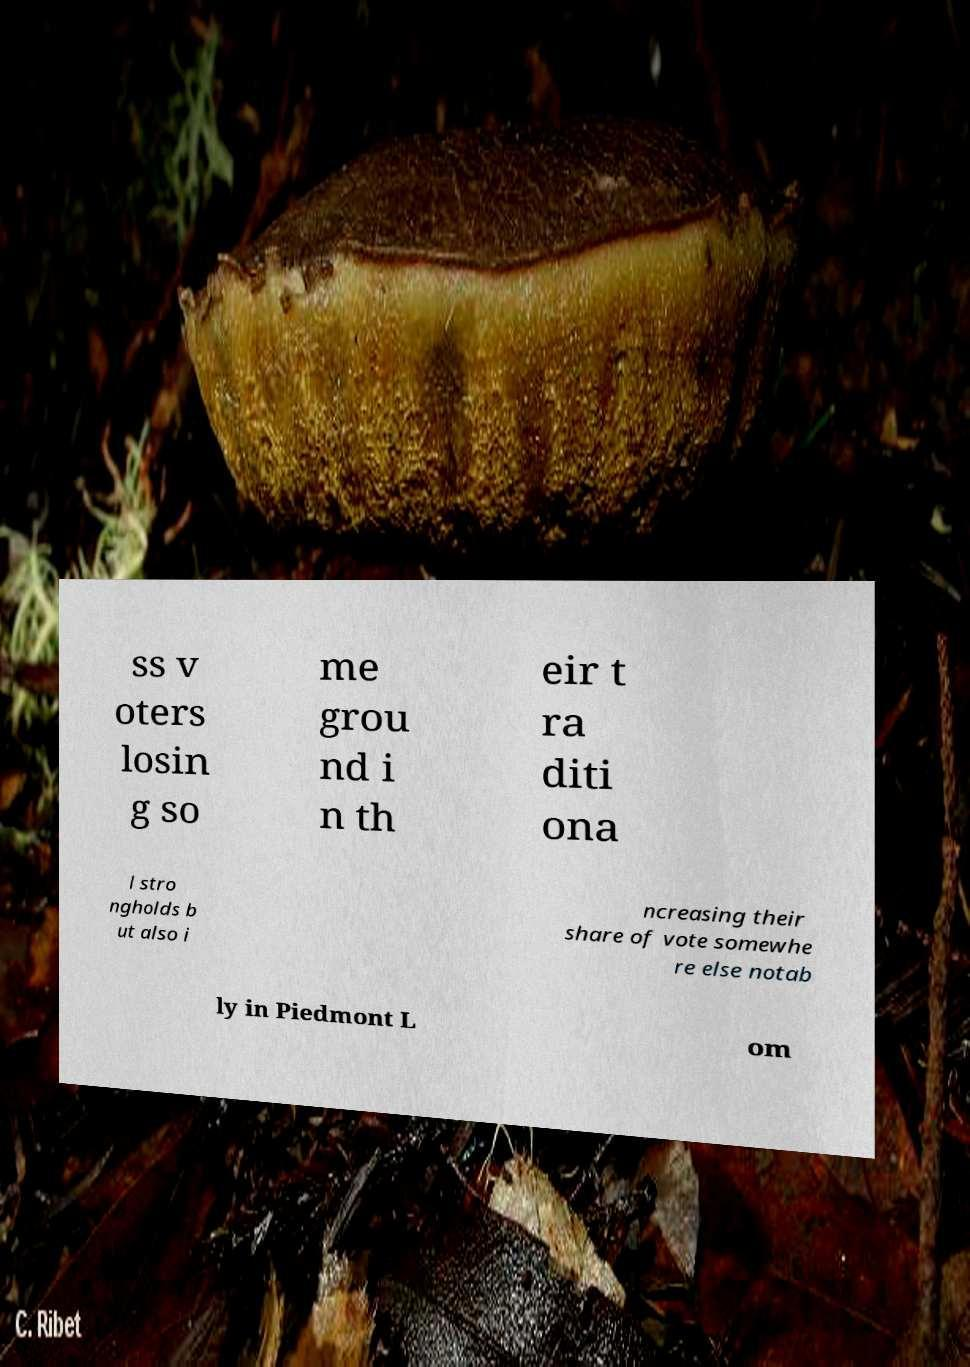What messages or text are displayed in this image? I need them in a readable, typed format. ss v oters losin g so me grou nd i n th eir t ra diti ona l stro ngholds b ut also i ncreasing their share of vote somewhe re else notab ly in Piedmont L om 